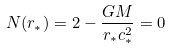Convert formula to latex. <formula><loc_0><loc_0><loc_500><loc_500>N ( r _ { * } ) = 2 - \frac { G M } { r _ { * } c _ { * } ^ { 2 } } = 0</formula> 